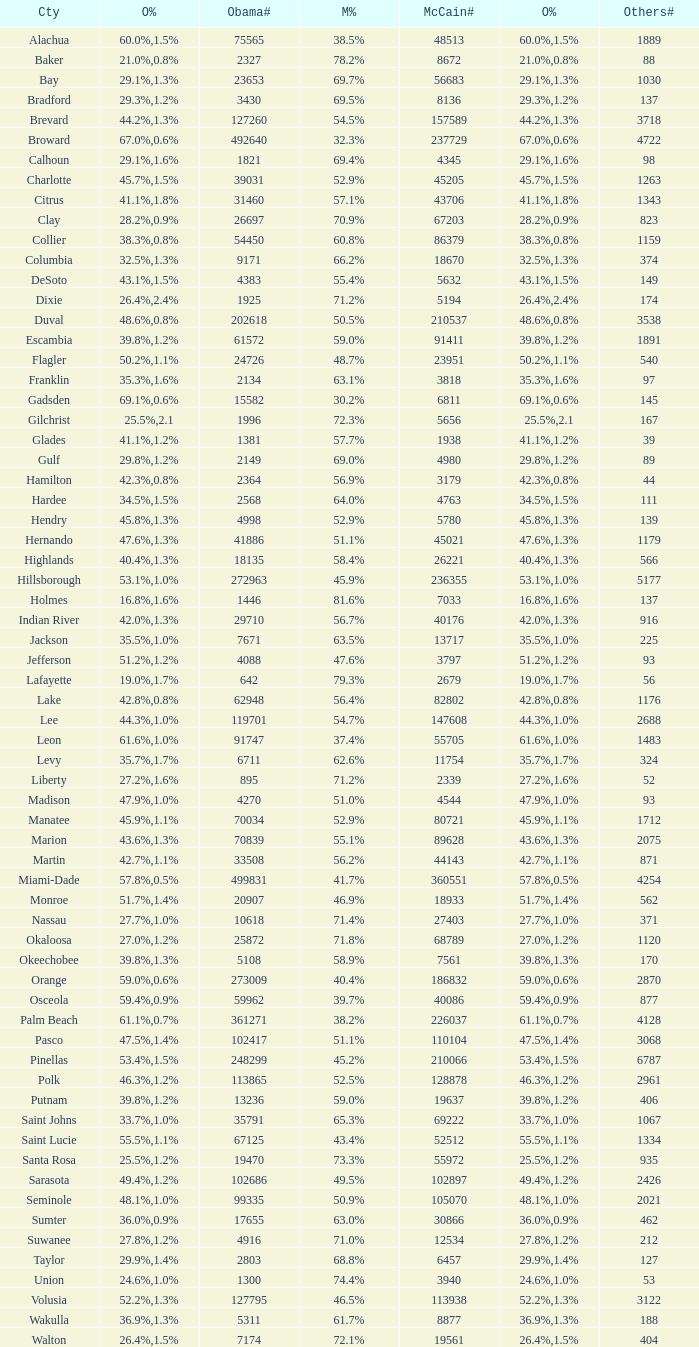What was the number of others votes in Columbia county? 374.0. 